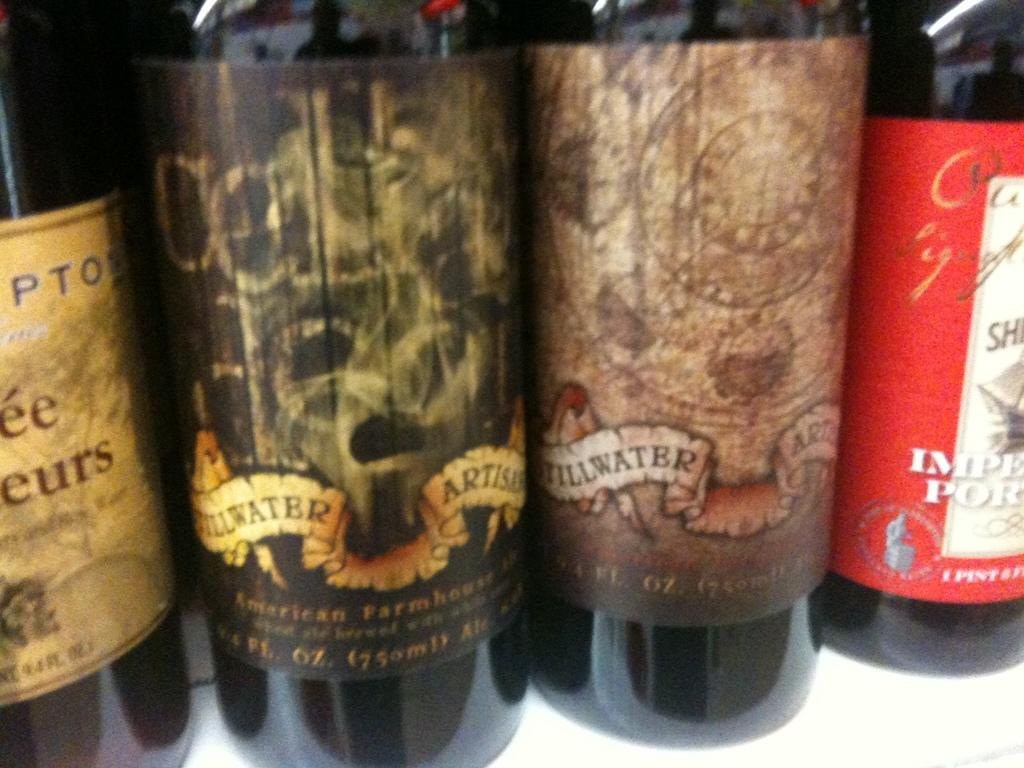Provide a one-sentence caption for the provided image. Some bottles of wine,  two of which have the words Stillwater visible. 